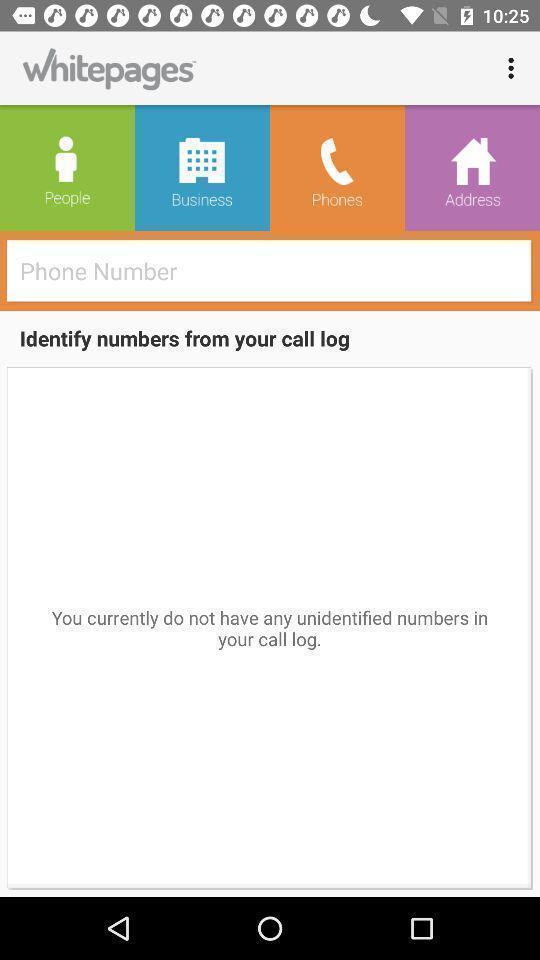Provide a description of this screenshot. Screen showing identify numbers from your call log. 